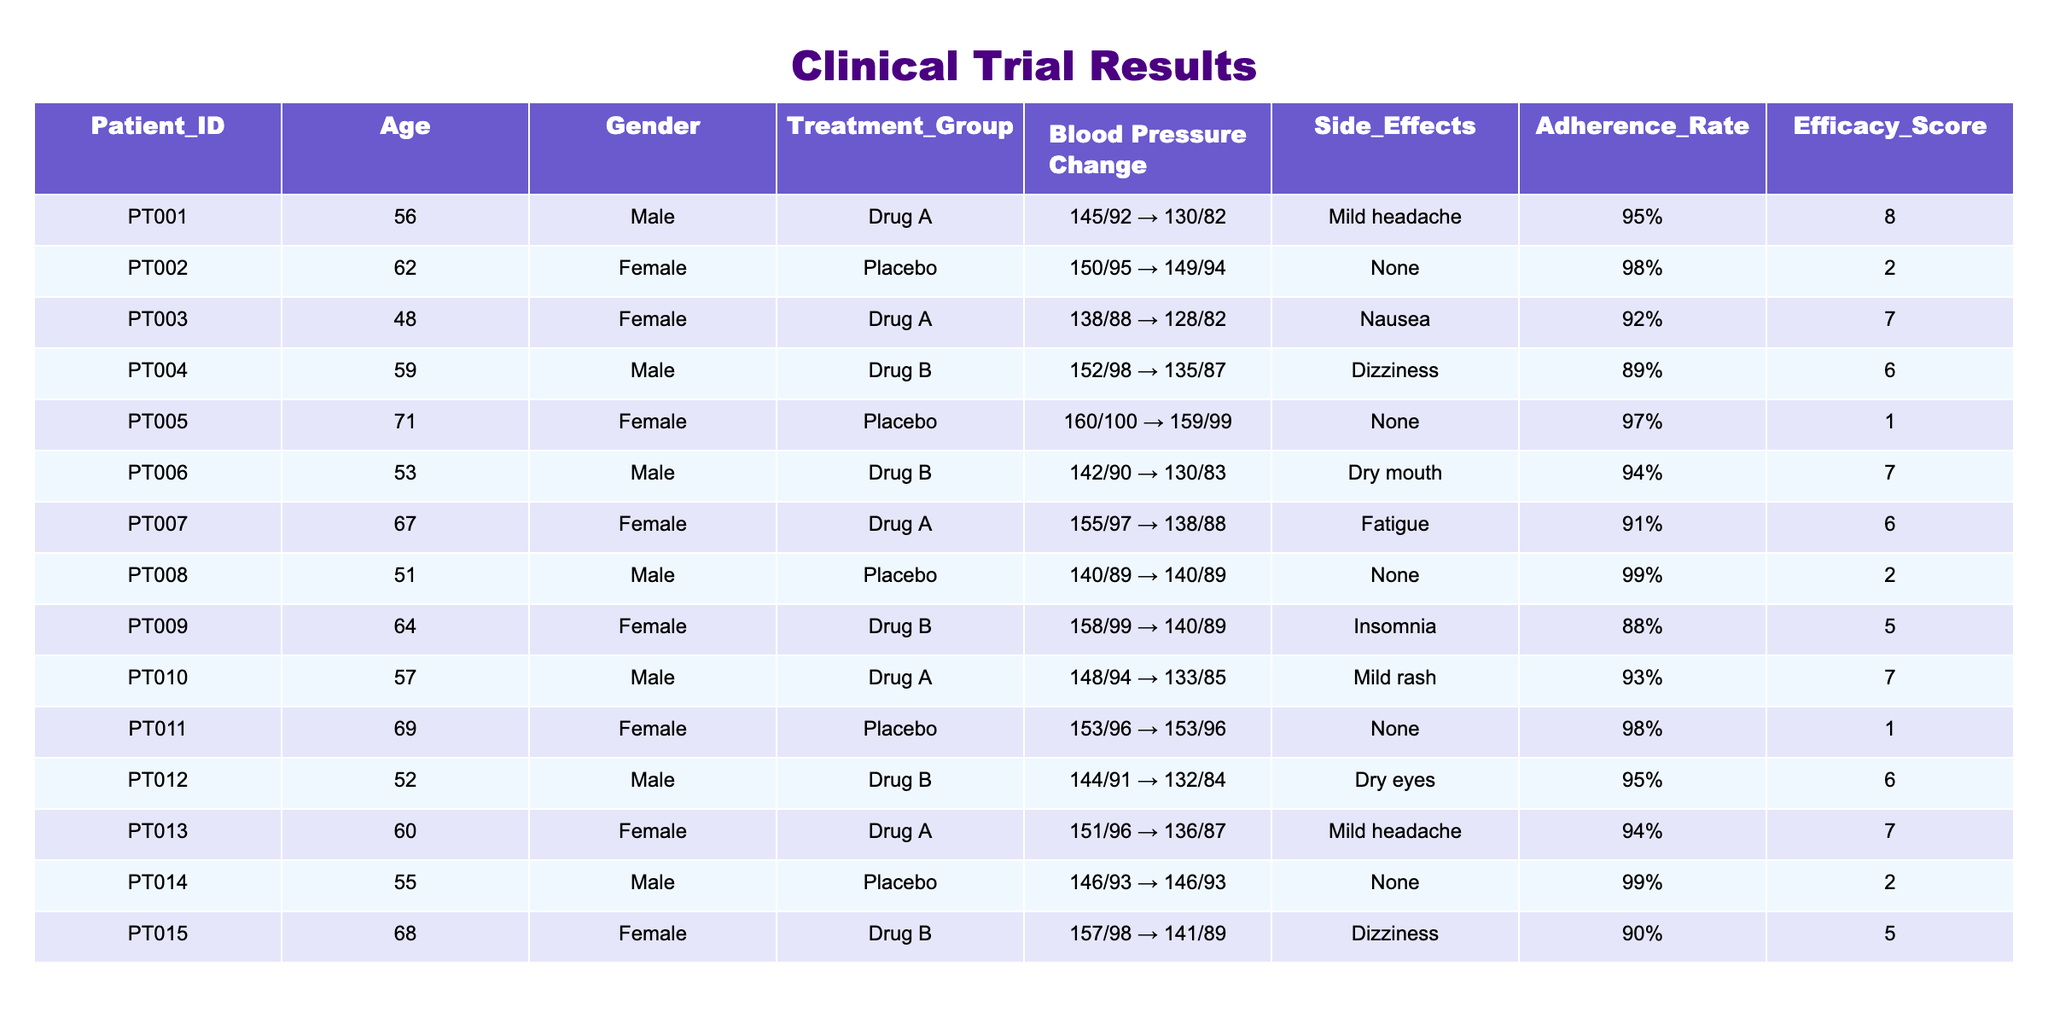What is the average efficacy score of patients on Drug A? To find the average efficacy score for Drug A, we first identify the efficacy scores of patients in this treatment group: PT001 (8), PT003 (7), PT007 (6), PT010 (7), PT013 (7). Then we sum these scores: 8 + 7 + 6 + 7 + 7 = 35, and divide by the number of patients (5): 35 / 5 = 7.
Answer: 7 How many patients reported side effects while on the placebo? From the table, we identify the patients in the placebo group: PT002, PT005, PT008, PT011, and PT014. Among these, the side effects reported are PT002 (None), PT005 (None), PT008 (None), PT011 (None), PT014 (None). Therefore, zero patients reported side effects while on the placebo.
Answer: 0 What is the blood pressure change for Patient PT006? For Patient PT006, the baseline blood pressure is 142/90 and the week 12 blood pressure is 130/83. Therefore, the blood pressure change can be represented as: "142/90 → 130/83".
Answer: 142/90 → 130/83 Which treatment group had the highest average adherence rate? The adherence rates for the treatment groups are: Drug A (95%, 92%, 91%, 93%, 94%), Drug B (89%, 94%, 95%, 90%), and Placebo (98%, 97%, 99%, 98%, 99%). For Drug A, the average is (95 + 92 + 91 + 93 + 94) / 5 = 93, for Drug B it's (89 + 94 + 95 + 90) / 4 = 92, and for Placebo it's (98 + 97 + 99 + 98 + 99) / 5 = 98. Thus, Placebo had the highest average adherence rate.
Answer: Placebo Is there a patient that experienced nausea while taking Drug A? Referring to the side effects column for Drug A, we see that PT001 reports mild headache, PT003 reports nausea, PT007 reports fatigue, PT010 reports mild rash, and PT013 reports mild headache. Since PT003 experienced nausea while on Drug A, the statement is true.
Answer: Yes How many patients had a decrease in blood pressure by Week 12 compared to their baseline? By analyzing the blood pressure readings, we compare the baseline and week 12 pressures for each patient. The counts for decreases are: PT001 (yes), PT002 (no), PT003 (yes), PT004 (yes), PT005 (no), PT006 (yes), PT007 (yes), PT008 (no), PT009 (yes), PT010 (yes), PT011 (no), PT012 (yes), PT013 (yes), PT014 (no), PT015 (yes). There are a total of 9 patients with decreased blood pressure by Week 12.
Answer: 9 What is the side effect reported by Patient PT014? For Patient PT014, the side effects column indicates "None". Therefore, the side effect reported is none.
Answer: None Among the patients who received Drug B, who had the highest initial blood pressure? The initial blood pressures for Drug B are: PT004 (152/98), PT006 (142/90), PT009 (158/99), PT012 (144/91), and PT015 (157/98). The highest initial blood pressure is PT009 with 158/99.
Answer: PT009 Which gender had the highest average blood pressure at baseline? The baseline blood pressures categorized by gender are: Males (PT001 145/92, PT004 152/98, PT006 142/90, PT010 148/94, PT012 144/91, PT015 157/98) averages to (145 + 152 + 142 + 148 + 144 + 157) / 6 = 145.67 mm Hg; Females (PT002 150/95, PT003 138/88, PT005 160/100, PT007 155/97, PT009 158/99, PT011 153/96, PT013 151/96, PT015 157/98) averages to (150 + 138 + 160 + 155 + 158 + 153 + 151 + 157) / 8 = 151.25 mm Hg, with females having the higher average.
Answer: Female Have any patients achieved an efficacy score greater than 8? Reviewing the efficacy scores, the scores are 8, 2, 7, 6, 1, 7, 6, 2, 5, 7, 1, 6, 7, 2, and 5. None of these scores are greater than 8, so the statement is false.
Answer: No 